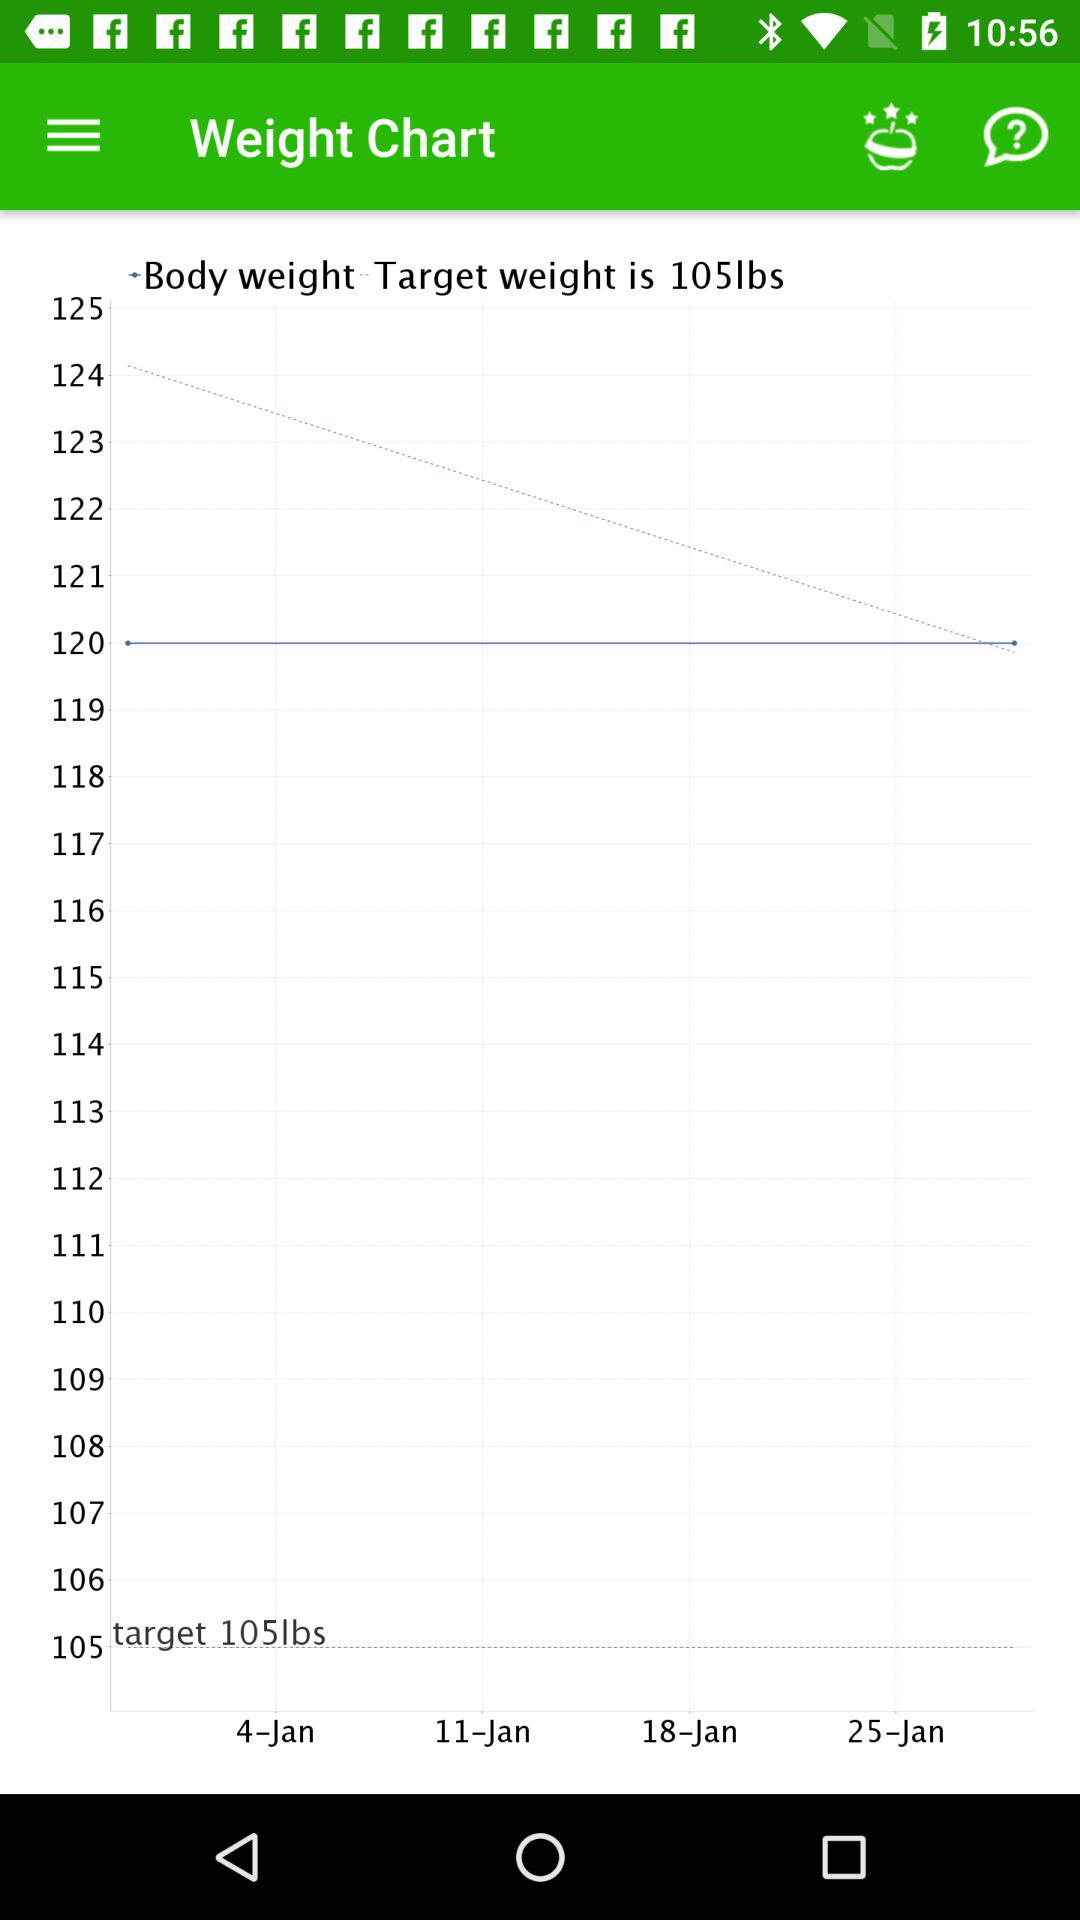What's the target weight? The target weight is 105 lbs. 